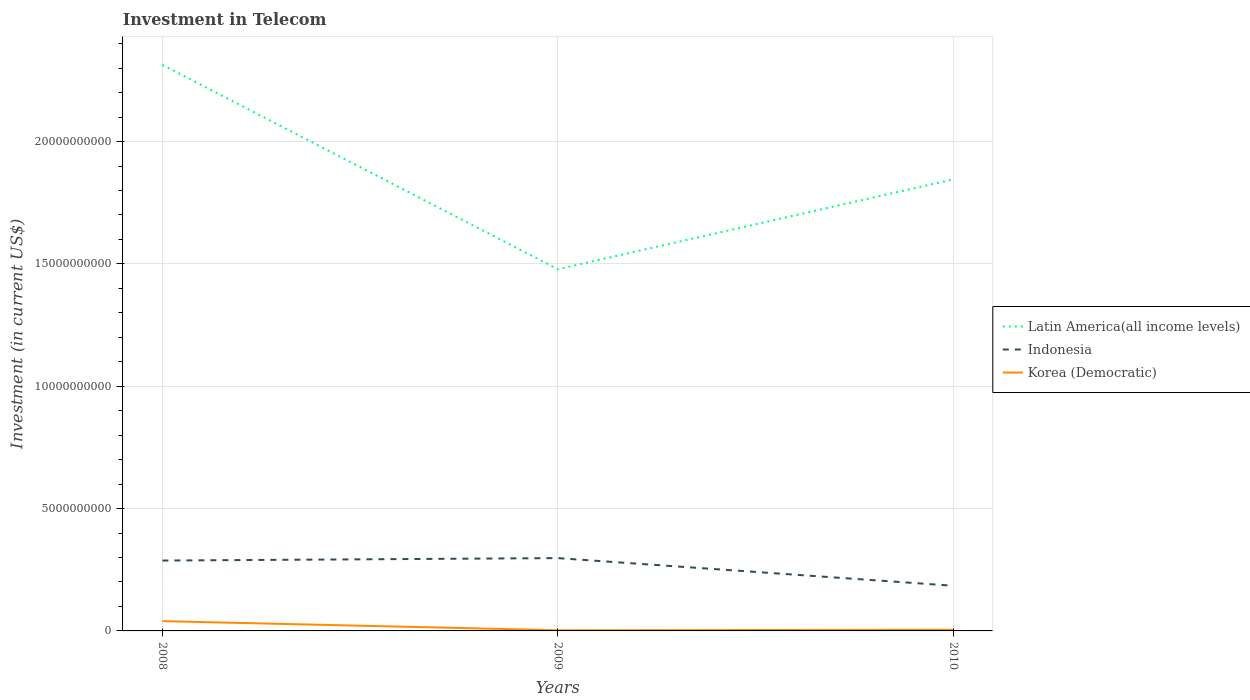Is the number of lines equal to the number of legend labels?
Provide a succinct answer. Yes. Across all years, what is the maximum amount invested in telecom in Latin America(all income levels)?
Keep it short and to the point. 1.48e+1. What is the total amount invested in telecom in Indonesia in the graph?
Make the answer very short. 1.03e+09. What is the difference between the highest and the second highest amount invested in telecom in Korea (Democratic)?
Offer a very short reply. 3.73e+08. What is the difference between the highest and the lowest amount invested in telecom in Indonesia?
Your answer should be compact. 2. How many lines are there?
Make the answer very short. 3. How many years are there in the graph?
Provide a succinct answer. 3. Does the graph contain grids?
Provide a short and direct response. Yes. What is the title of the graph?
Your response must be concise. Investment in Telecom. What is the label or title of the X-axis?
Make the answer very short. Years. What is the label or title of the Y-axis?
Your response must be concise. Investment (in current US$). What is the Investment (in current US$) of Latin America(all income levels) in 2008?
Offer a very short reply. 2.31e+1. What is the Investment (in current US$) in Indonesia in 2008?
Offer a very short reply. 2.88e+09. What is the Investment (in current US$) in Korea (Democratic) in 2008?
Offer a very short reply. 4.00e+08. What is the Investment (in current US$) of Latin America(all income levels) in 2009?
Your answer should be very brief. 1.48e+1. What is the Investment (in current US$) in Indonesia in 2009?
Ensure brevity in your answer.  2.98e+09. What is the Investment (in current US$) of Korea (Democratic) in 2009?
Provide a short and direct response. 2.70e+07. What is the Investment (in current US$) of Latin America(all income levels) in 2010?
Offer a terse response. 1.85e+1. What is the Investment (in current US$) of Indonesia in 2010?
Your answer should be very brief. 1.85e+09. What is the Investment (in current US$) in Korea (Democratic) in 2010?
Your answer should be compact. 4.70e+07. Across all years, what is the maximum Investment (in current US$) in Latin America(all income levels)?
Offer a terse response. 2.31e+1. Across all years, what is the maximum Investment (in current US$) in Indonesia?
Your response must be concise. 2.98e+09. Across all years, what is the maximum Investment (in current US$) of Korea (Democratic)?
Your response must be concise. 4.00e+08. Across all years, what is the minimum Investment (in current US$) in Latin America(all income levels)?
Ensure brevity in your answer.  1.48e+1. Across all years, what is the minimum Investment (in current US$) in Indonesia?
Offer a terse response. 1.85e+09. Across all years, what is the minimum Investment (in current US$) in Korea (Democratic)?
Provide a short and direct response. 2.70e+07. What is the total Investment (in current US$) in Latin America(all income levels) in the graph?
Your response must be concise. 5.64e+1. What is the total Investment (in current US$) in Indonesia in the graph?
Ensure brevity in your answer.  7.70e+09. What is the total Investment (in current US$) of Korea (Democratic) in the graph?
Keep it short and to the point. 4.74e+08. What is the difference between the Investment (in current US$) in Latin America(all income levels) in 2008 and that in 2009?
Provide a succinct answer. 8.35e+09. What is the difference between the Investment (in current US$) in Indonesia in 2008 and that in 2009?
Your answer should be compact. -9.99e+07. What is the difference between the Investment (in current US$) of Korea (Democratic) in 2008 and that in 2009?
Provide a succinct answer. 3.73e+08. What is the difference between the Investment (in current US$) of Latin America(all income levels) in 2008 and that in 2010?
Your answer should be compact. 4.68e+09. What is the difference between the Investment (in current US$) in Indonesia in 2008 and that in 2010?
Provide a short and direct response. 1.03e+09. What is the difference between the Investment (in current US$) of Korea (Democratic) in 2008 and that in 2010?
Provide a succinct answer. 3.53e+08. What is the difference between the Investment (in current US$) of Latin America(all income levels) in 2009 and that in 2010?
Your answer should be compact. -3.67e+09. What is the difference between the Investment (in current US$) in Indonesia in 2009 and that in 2010?
Your response must be concise. 1.13e+09. What is the difference between the Investment (in current US$) in Korea (Democratic) in 2009 and that in 2010?
Your answer should be very brief. -2.00e+07. What is the difference between the Investment (in current US$) in Latin America(all income levels) in 2008 and the Investment (in current US$) in Indonesia in 2009?
Provide a short and direct response. 2.02e+1. What is the difference between the Investment (in current US$) in Latin America(all income levels) in 2008 and the Investment (in current US$) in Korea (Democratic) in 2009?
Make the answer very short. 2.31e+1. What is the difference between the Investment (in current US$) in Indonesia in 2008 and the Investment (in current US$) in Korea (Democratic) in 2009?
Provide a succinct answer. 2.85e+09. What is the difference between the Investment (in current US$) of Latin America(all income levels) in 2008 and the Investment (in current US$) of Indonesia in 2010?
Give a very brief answer. 2.13e+1. What is the difference between the Investment (in current US$) in Latin America(all income levels) in 2008 and the Investment (in current US$) in Korea (Democratic) in 2010?
Keep it short and to the point. 2.31e+1. What is the difference between the Investment (in current US$) of Indonesia in 2008 and the Investment (in current US$) of Korea (Democratic) in 2010?
Ensure brevity in your answer.  2.83e+09. What is the difference between the Investment (in current US$) in Latin America(all income levels) in 2009 and the Investment (in current US$) in Indonesia in 2010?
Make the answer very short. 1.29e+1. What is the difference between the Investment (in current US$) of Latin America(all income levels) in 2009 and the Investment (in current US$) of Korea (Democratic) in 2010?
Ensure brevity in your answer.  1.47e+1. What is the difference between the Investment (in current US$) in Indonesia in 2009 and the Investment (in current US$) in Korea (Democratic) in 2010?
Offer a terse response. 2.93e+09. What is the average Investment (in current US$) of Latin America(all income levels) per year?
Offer a very short reply. 1.88e+1. What is the average Investment (in current US$) in Indonesia per year?
Your answer should be very brief. 2.57e+09. What is the average Investment (in current US$) in Korea (Democratic) per year?
Offer a very short reply. 1.58e+08. In the year 2008, what is the difference between the Investment (in current US$) of Latin America(all income levels) and Investment (in current US$) of Indonesia?
Your response must be concise. 2.03e+1. In the year 2008, what is the difference between the Investment (in current US$) of Latin America(all income levels) and Investment (in current US$) of Korea (Democratic)?
Give a very brief answer. 2.27e+1. In the year 2008, what is the difference between the Investment (in current US$) of Indonesia and Investment (in current US$) of Korea (Democratic)?
Ensure brevity in your answer.  2.48e+09. In the year 2009, what is the difference between the Investment (in current US$) of Latin America(all income levels) and Investment (in current US$) of Indonesia?
Ensure brevity in your answer.  1.18e+1. In the year 2009, what is the difference between the Investment (in current US$) in Latin America(all income levels) and Investment (in current US$) in Korea (Democratic)?
Your answer should be compact. 1.48e+1. In the year 2009, what is the difference between the Investment (in current US$) in Indonesia and Investment (in current US$) in Korea (Democratic)?
Provide a succinct answer. 2.95e+09. In the year 2010, what is the difference between the Investment (in current US$) in Latin America(all income levels) and Investment (in current US$) in Indonesia?
Keep it short and to the point. 1.66e+1. In the year 2010, what is the difference between the Investment (in current US$) in Latin America(all income levels) and Investment (in current US$) in Korea (Democratic)?
Keep it short and to the point. 1.84e+1. In the year 2010, what is the difference between the Investment (in current US$) in Indonesia and Investment (in current US$) in Korea (Democratic)?
Your answer should be compact. 1.80e+09. What is the ratio of the Investment (in current US$) of Latin America(all income levels) in 2008 to that in 2009?
Provide a short and direct response. 1.57. What is the ratio of the Investment (in current US$) of Indonesia in 2008 to that in 2009?
Offer a terse response. 0.97. What is the ratio of the Investment (in current US$) of Korea (Democratic) in 2008 to that in 2009?
Provide a short and direct response. 14.81. What is the ratio of the Investment (in current US$) of Latin America(all income levels) in 2008 to that in 2010?
Ensure brevity in your answer.  1.25. What is the ratio of the Investment (in current US$) of Indonesia in 2008 to that in 2010?
Give a very brief answer. 1.56. What is the ratio of the Investment (in current US$) of Korea (Democratic) in 2008 to that in 2010?
Give a very brief answer. 8.51. What is the ratio of the Investment (in current US$) of Latin America(all income levels) in 2009 to that in 2010?
Keep it short and to the point. 0.8. What is the ratio of the Investment (in current US$) of Indonesia in 2009 to that in 2010?
Give a very brief answer. 1.61. What is the ratio of the Investment (in current US$) of Korea (Democratic) in 2009 to that in 2010?
Make the answer very short. 0.57. What is the difference between the highest and the second highest Investment (in current US$) of Latin America(all income levels)?
Provide a short and direct response. 4.68e+09. What is the difference between the highest and the second highest Investment (in current US$) in Indonesia?
Provide a short and direct response. 9.99e+07. What is the difference between the highest and the second highest Investment (in current US$) of Korea (Democratic)?
Provide a short and direct response. 3.53e+08. What is the difference between the highest and the lowest Investment (in current US$) of Latin America(all income levels)?
Your response must be concise. 8.35e+09. What is the difference between the highest and the lowest Investment (in current US$) of Indonesia?
Give a very brief answer. 1.13e+09. What is the difference between the highest and the lowest Investment (in current US$) in Korea (Democratic)?
Give a very brief answer. 3.73e+08. 